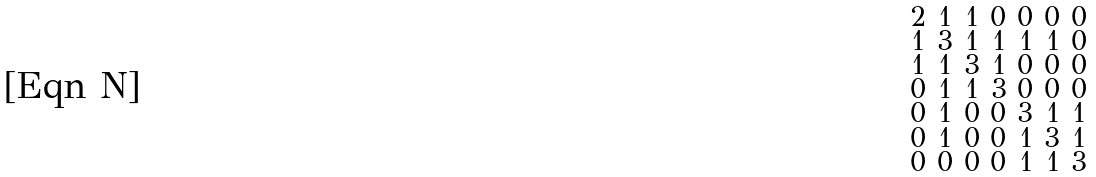<formula> <loc_0><loc_0><loc_500><loc_500>\begin{smallmatrix} 2 & 1 & 1 & 0 & 0 & 0 & 0 \\ 1 & 3 & 1 & 1 & 1 & 1 & 0 \\ 1 & 1 & 3 & 1 & 0 & 0 & 0 \\ 0 & 1 & 1 & 3 & 0 & 0 & 0 \\ 0 & 1 & 0 & 0 & 3 & 1 & 1 \\ 0 & 1 & 0 & 0 & 1 & 3 & 1 \\ 0 & 0 & 0 & 0 & 1 & 1 & 3 \end{smallmatrix}</formula> 